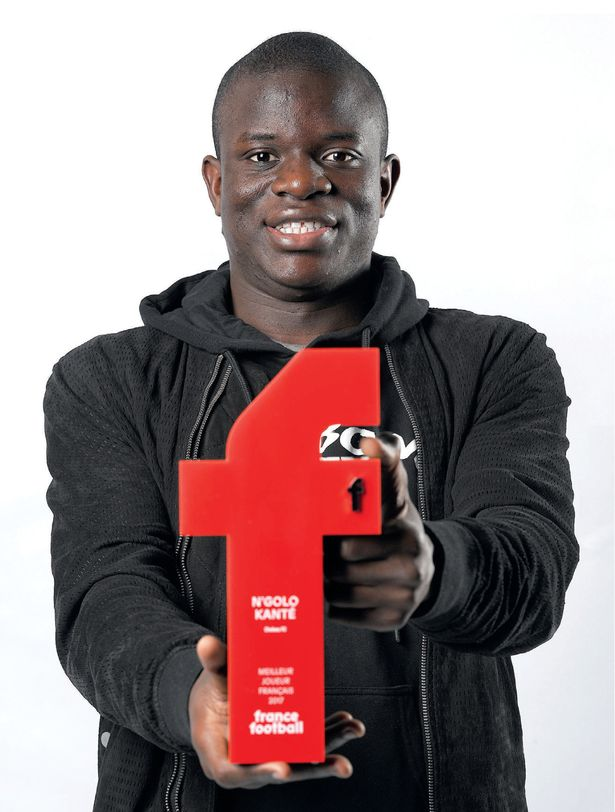Imagine a scenario where the recipient of this award has to play in a critical match with an injury. What strategies might they and the team employ to maximize effectiveness? In such a scenario, the team and player might employ several strategies to maximize effectiveness while mitigating the injury's impact. The player could modify their play style to avoid exacerbating the injury, relying more on intelligence, positioning, and passing rather than physicality. The coaching staff might adjust the team's tactics to provide additional support, such as assigning other players to cover more ground or take on more physically demanding roles. Additionally, medical staff will work closely with the player to manage pain and monitor the injury's status. Communication within the team will be crucial to ensure everyone is aware of the situation and can adapt accordingly. 